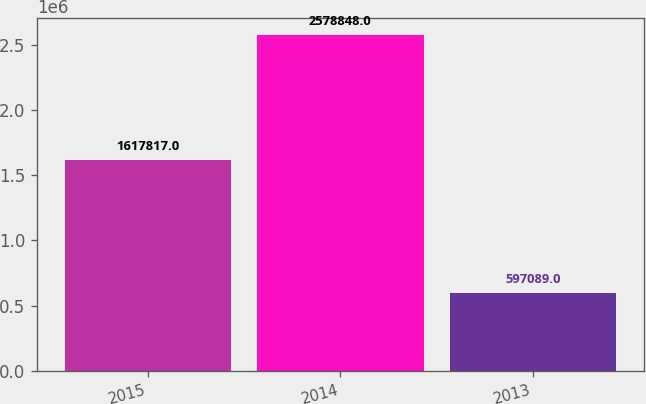<chart> <loc_0><loc_0><loc_500><loc_500><bar_chart><fcel>2015<fcel>2014<fcel>2013<nl><fcel>1.61782e+06<fcel>2.57885e+06<fcel>597089<nl></chart> 